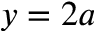Convert formula to latex. <formula><loc_0><loc_0><loc_500><loc_500>y = 2 a</formula> 